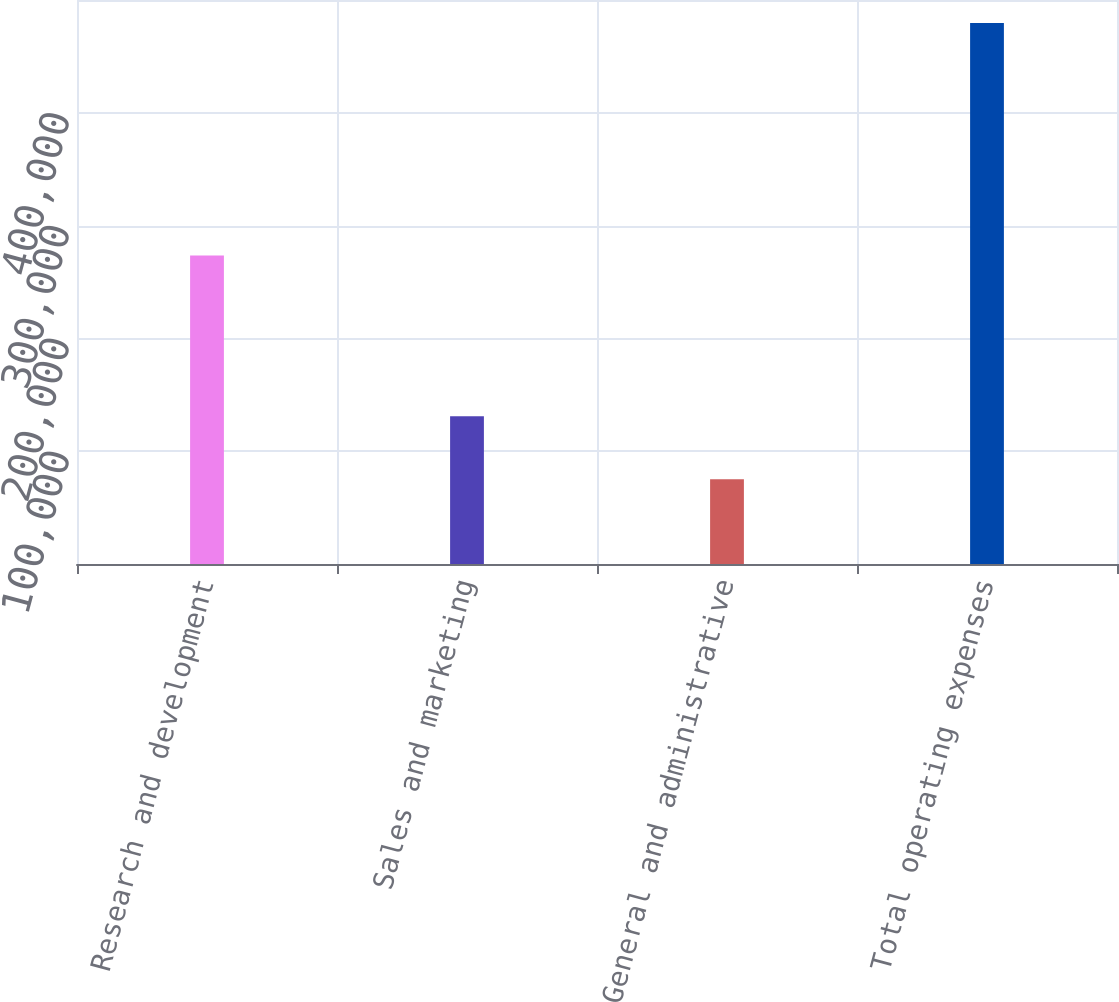<chart> <loc_0><loc_0><loc_500><loc_500><bar_chart><fcel>Research and development<fcel>Sales and marketing<fcel>General and administrative<fcel>Total operating expenses<nl><fcel>273581<fcel>130887<fcel>75239<fcel>479707<nl></chart> 